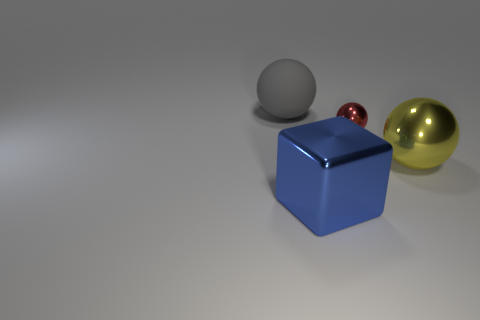Are there any other things that are the same size as the red metal ball?
Make the answer very short. No. Are there any other things that have the same color as the tiny sphere?
Your answer should be very brief. No. There is another small thing that is the same shape as the yellow metallic object; what color is it?
Ensure brevity in your answer.  Red. Is the number of matte balls that are on the right side of the rubber object greater than the number of large gray objects?
Offer a terse response. No. What color is the metallic object in front of the yellow ball?
Make the answer very short. Blue. Do the blue metallic cube and the yellow shiny thing have the same size?
Offer a very short reply. Yes. The shiny block has what size?
Provide a succinct answer. Large. Are there more small things than large gray shiny cylinders?
Give a very brief answer. Yes. What color is the large sphere that is left of the big ball that is in front of the ball to the left of the blue cube?
Ensure brevity in your answer.  Gray. Is the shape of the shiny object that is to the left of the small red object the same as  the large yellow thing?
Keep it short and to the point. No. 